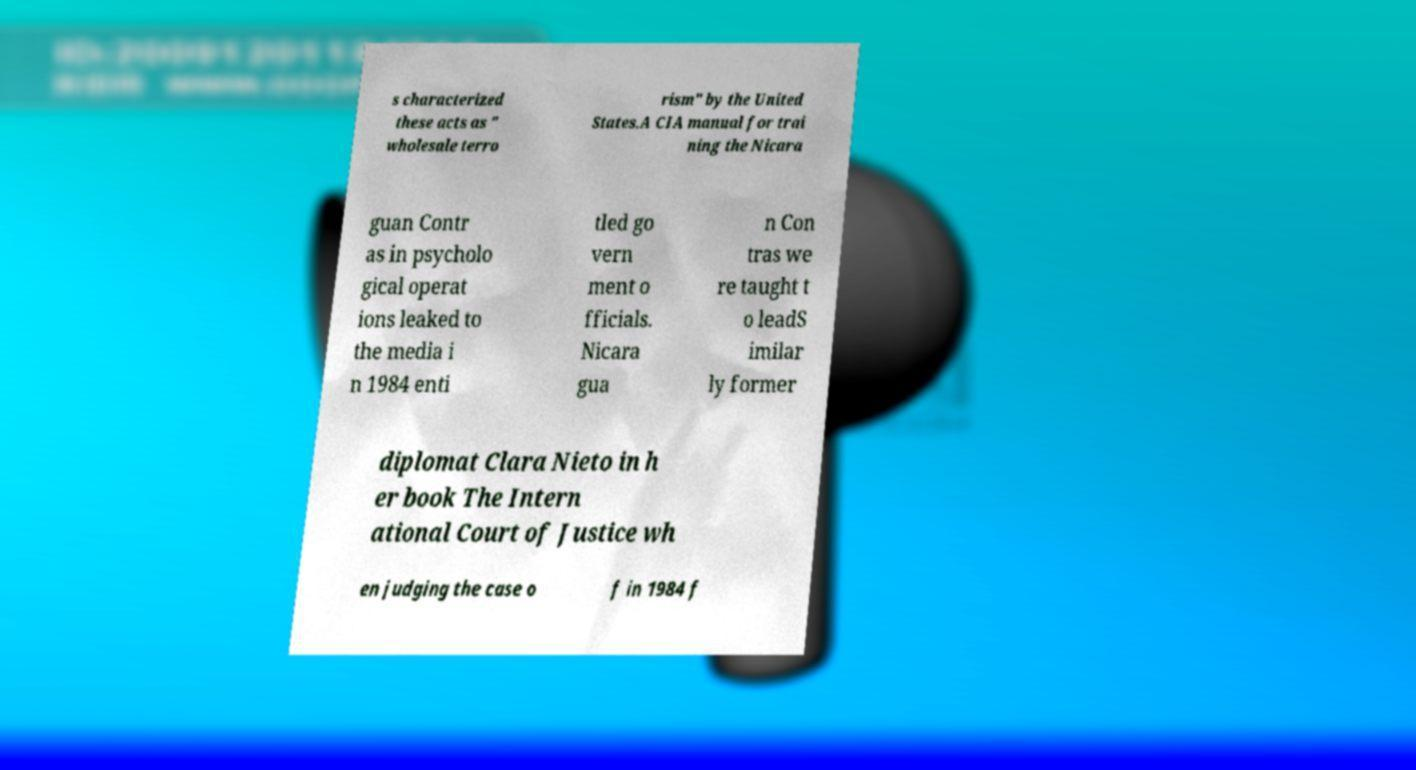I need the written content from this picture converted into text. Can you do that? s characterized these acts as " wholesale terro rism" by the United States.A CIA manual for trai ning the Nicara guan Contr as in psycholo gical operat ions leaked to the media i n 1984 enti tled go vern ment o fficials. Nicara gua n Con tras we re taught t o leadS imilar ly former diplomat Clara Nieto in h er book The Intern ational Court of Justice wh en judging the case o f in 1984 f 